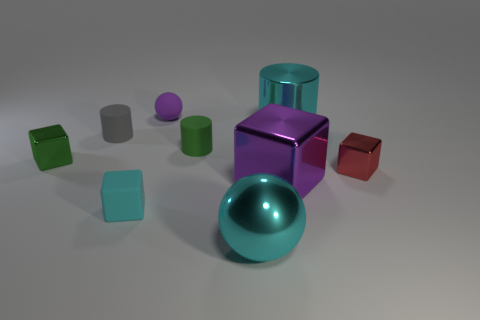What size is the ball that is the same color as the large metal cylinder?
Your answer should be very brief. Large. Is there a metallic thing that has the same color as the rubber sphere?
Keep it short and to the point. Yes. There is a purple object that is the same shape as the tiny cyan matte thing; what size is it?
Your answer should be very brief. Large. What shape is the big object that is the same color as the tiny sphere?
Your response must be concise. Cube. There is a green metal object; what shape is it?
Your answer should be compact. Cube. Are there the same number of tiny blocks on the right side of the large ball and red things?
Provide a succinct answer. Yes. Is there any other thing that is the same material as the cyan ball?
Your answer should be compact. Yes. Do the cyan object to the right of the big metal ball and the cyan sphere have the same material?
Your answer should be very brief. Yes. Is the number of cyan metal objects that are on the right side of the red shiny object less than the number of big yellow metallic objects?
Provide a succinct answer. No. How many metallic things are either big cylinders or cyan balls?
Provide a succinct answer. 2. 